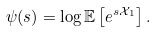Convert formula to latex. <formula><loc_0><loc_0><loc_500><loc_500>\psi ( s ) = \log \mathbb { E } \left [ e ^ { s \mathcal { X } _ { 1 } } \right ] .</formula> 